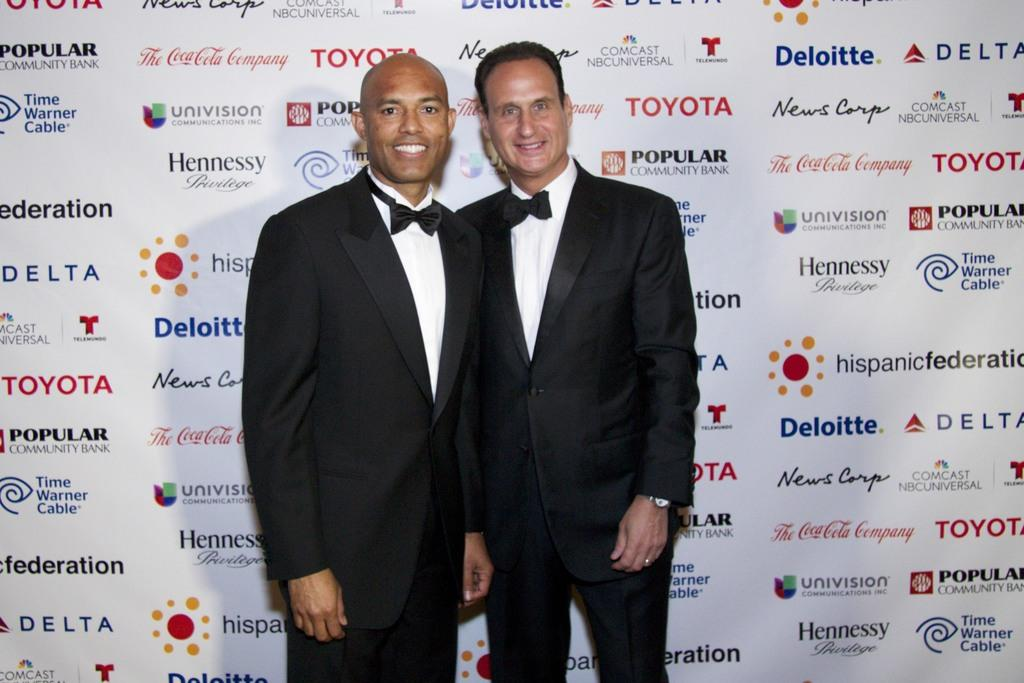How many people are in the image? There are two persons in the image. What are the persons wearing? The persons are wearing suits. What are the persons doing in the image? The persons are posing for a photograph. What can be seen in the background of the image? There is a poster in the background of the image. What is featured on the poster? The poster contains company names. What type of oatmeal is being served at the event in the image? There is no event or oatmeal present in the image; it features two persons posing for a photograph with a poster in the background. 